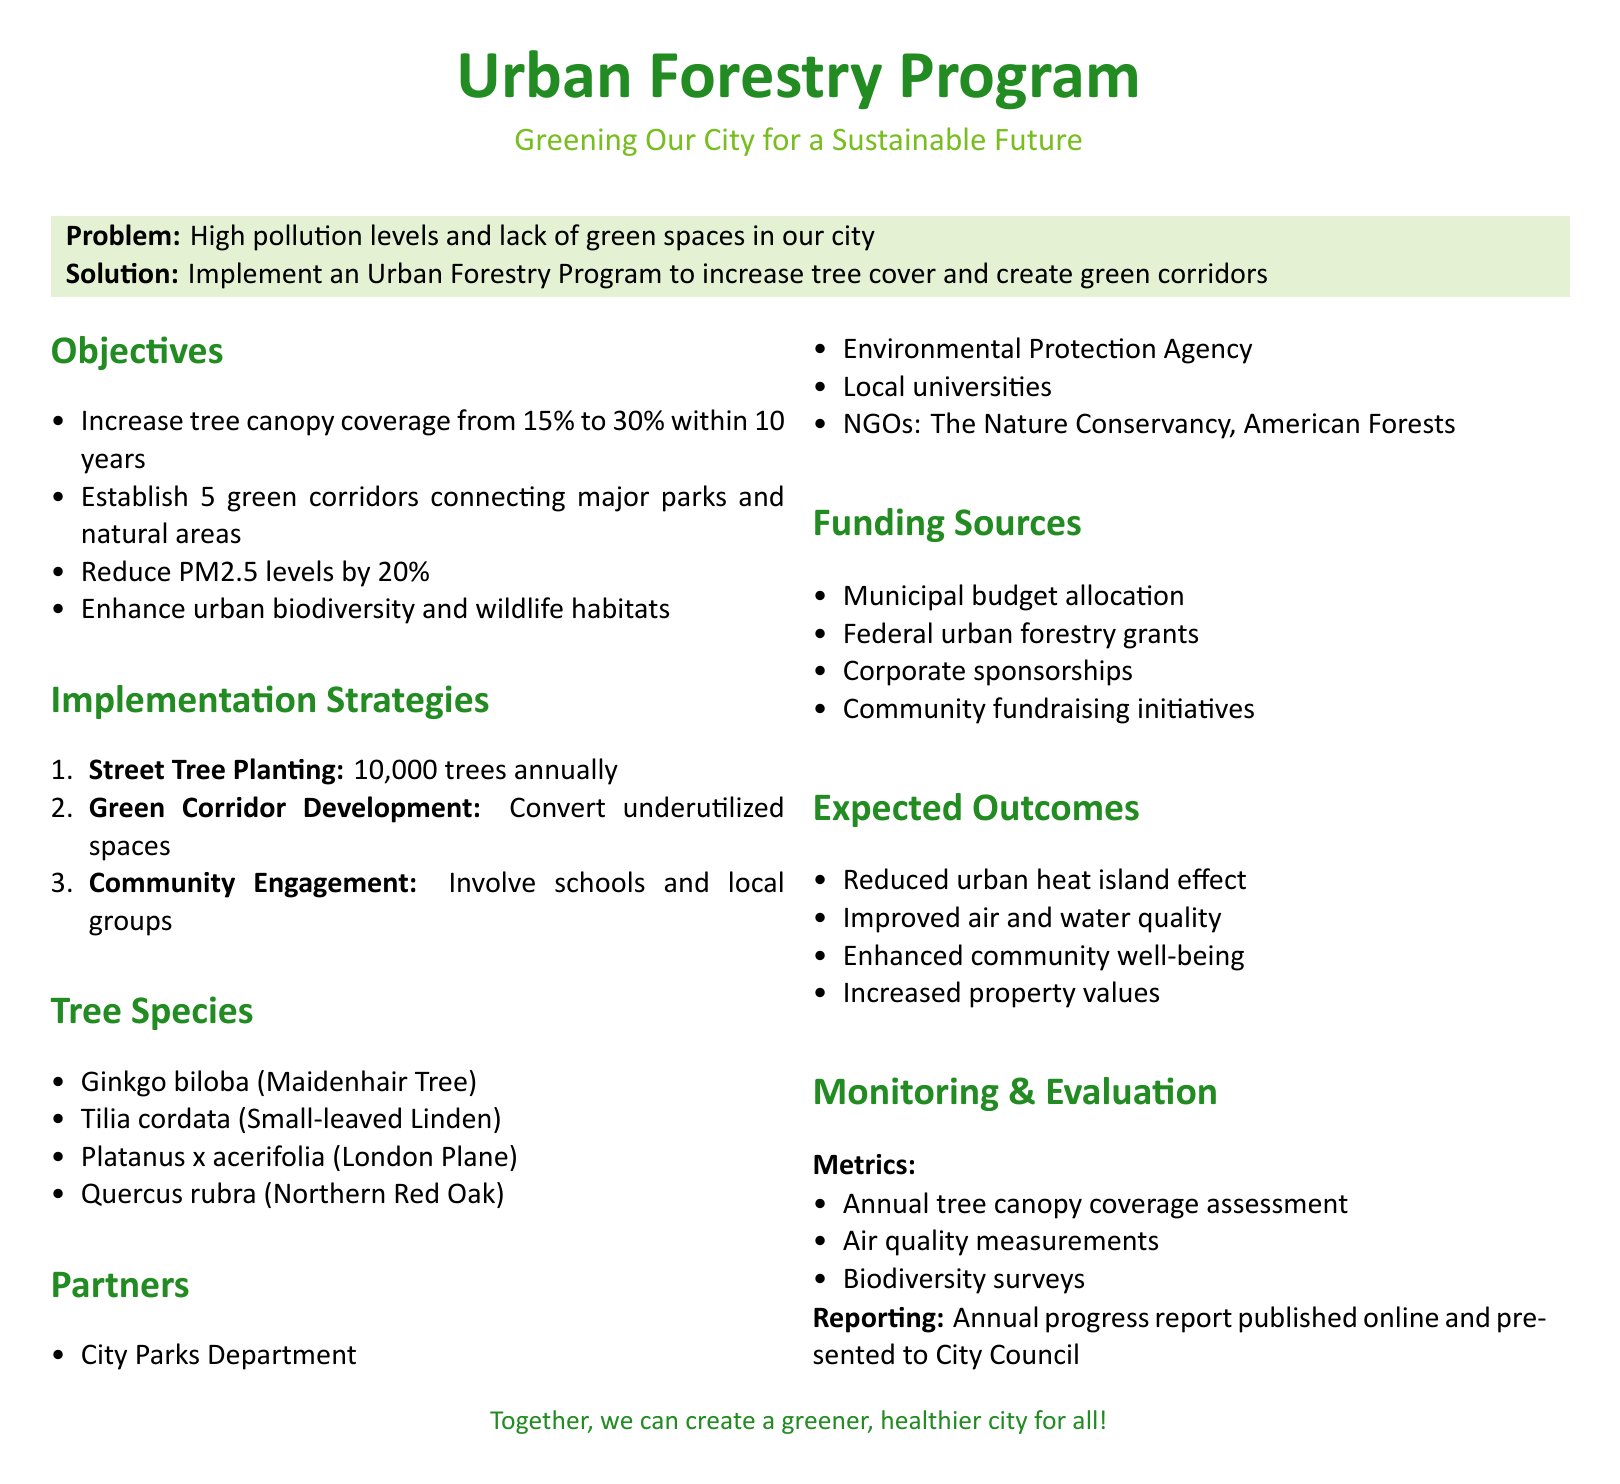What is the current tree canopy coverage? The document states that the current tree canopy coverage is 15%.
Answer: 15% How many trees will be planted annually? The document specifies that 10,000 trees will be planted annually.
Answer: 10,000 trees What percentage reduction in PM2.5 levels is aimed for? The proposed reduction in PM2.5 levels is 20%.
Answer: 20% What is the primary goal of the Urban Forestry Program? The primary goal is to increase tree cover and create green corridors.
Answer: Increase tree cover and create green corridors Which organization is a partner in the program? The Nature Conservancy is listed as one of the partners in the program.
Answer: The Nature Conservancy How many green corridors are planned? The document indicates that 5 green corridors are to be established.
Answer: 5 What is one expected outcome of the program? An expected outcome is improved air and water quality.
Answer: Improved air and water quality What tree species is known as the Maidenhair Tree? Ginkgo biloba is identified as the Maidenhair Tree in the document.
Answer: Ginkgo biloba What metric is used to assess tree canopy coverage? The metric used is annual tree canopy coverage assessment.
Answer: Annual tree canopy coverage assessment 